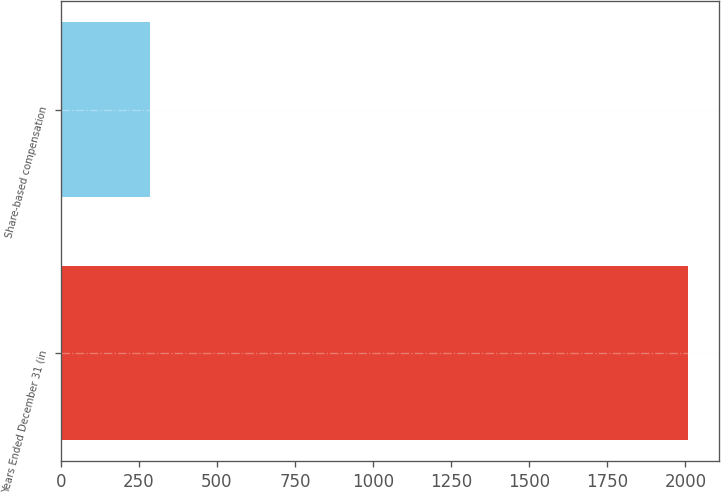Convert chart to OTSL. <chart><loc_0><loc_0><loc_500><loc_500><bar_chart><fcel>Years Ended December 31 (in<fcel>Share-based compensation<nl><fcel>2008<fcel>284<nl></chart> 